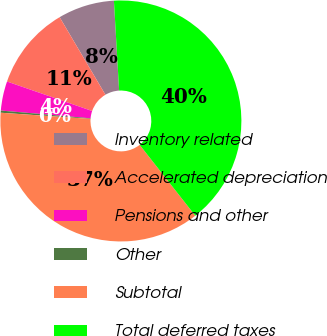Convert chart. <chart><loc_0><loc_0><loc_500><loc_500><pie_chart><fcel>Inventory related<fcel>Accelerated depreciation<fcel>Pensions and other<fcel>Other<fcel>Subtotal<fcel>Total deferred taxes<nl><fcel>7.57%<fcel>11.21%<fcel>3.93%<fcel>0.29%<fcel>36.69%<fcel>40.33%<nl></chart> 